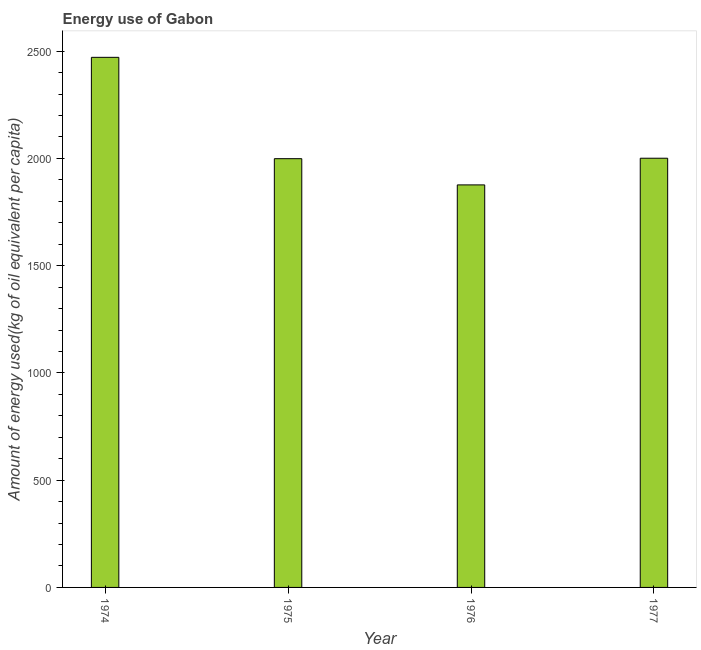Does the graph contain grids?
Make the answer very short. No. What is the title of the graph?
Offer a very short reply. Energy use of Gabon. What is the label or title of the X-axis?
Make the answer very short. Year. What is the label or title of the Y-axis?
Make the answer very short. Amount of energy used(kg of oil equivalent per capita). What is the amount of energy used in 1976?
Your answer should be very brief. 1876.54. Across all years, what is the maximum amount of energy used?
Keep it short and to the point. 2471.28. Across all years, what is the minimum amount of energy used?
Offer a very short reply. 1876.54. In which year was the amount of energy used maximum?
Offer a very short reply. 1974. In which year was the amount of energy used minimum?
Your answer should be compact. 1976. What is the sum of the amount of energy used?
Offer a very short reply. 8347.5. What is the difference between the amount of energy used in 1975 and 1977?
Provide a succinct answer. -2.12. What is the average amount of energy used per year?
Offer a very short reply. 2086.88. What is the median amount of energy used?
Make the answer very short. 1999.84. In how many years, is the amount of energy used greater than 600 kg?
Provide a succinct answer. 4. What is the ratio of the amount of energy used in 1974 to that in 1977?
Ensure brevity in your answer.  1.24. Is the amount of energy used in 1974 less than that in 1976?
Your response must be concise. No. What is the difference between the highest and the second highest amount of energy used?
Your answer should be very brief. 470.38. What is the difference between the highest and the lowest amount of energy used?
Offer a terse response. 594.73. In how many years, is the amount of energy used greater than the average amount of energy used taken over all years?
Your answer should be compact. 1. Are all the bars in the graph horizontal?
Offer a terse response. No. How many years are there in the graph?
Offer a very short reply. 4. Are the values on the major ticks of Y-axis written in scientific E-notation?
Provide a short and direct response. No. What is the Amount of energy used(kg of oil equivalent per capita) of 1974?
Keep it short and to the point. 2471.28. What is the Amount of energy used(kg of oil equivalent per capita) in 1975?
Offer a terse response. 1998.78. What is the Amount of energy used(kg of oil equivalent per capita) in 1976?
Your response must be concise. 1876.54. What is the Amount of energy used(kg of oil equivalent per capita) of 1977?
Offer a very short reply. 2000.9. What is the difference between the Amount of energy used(kg of oil equivalent per capita) in 1974 and 1975?
Give a very brief answer. 472.49. What is the difference between the Amount of energy used(kg of oil equivalent per capita) in 1974 and 1976?
Offer a terse response. 594.73. What is the difference between the Amount of energy used(kg of oil equivalent per capita) in 1974 and 1977?
Your answer should be compact. 470.38. What is the difference between the Amount of energy used(kg of oil equivalent per capita) in 1975 and 1976?
Your response must be concise. 122.24. What is the difference between the Amount of energy used(kg of oil equivalent per capita) in 1975 and 1977?
Provide a short and direct response. -2.12. What is the difference between the Amount of energy used(kg of oil equivalent per capita) in 1976 and 1977?
Ensure brevity in your answer.  -124.36. What is the ratio of the Amount of energy used(kg of oil equivalent per capita) in 1974 to that in 1975?
Your response must be concise. 1.24. What is the ratio of the Amount of energy used(kg of oil equivalent per capita) in 1974 to that in 1976?
Make the answer very short. 1.32. What is the ratio of the Amount of energy used(kg of oil equivalent per capita) in 1974 to that in 1977?
Your answer should be compact. 1.24. What is the ratio of the Amount of energy used(kg of oil equivalent per capita) in 1975 to that in 1976?
Offer a terse response. 1.06. What is the ratio of the Amount of energy used(kg of oil equivalent per capita) in 1976 to that in 1977?
Offer a very short reply. 0.94. 